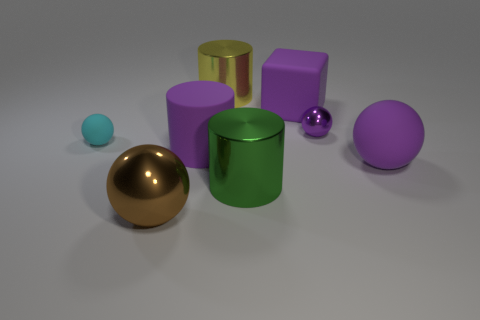What number of other objects are the same material as the large yellow thing?
Your response must be concise. 3. There is another sphere that is the same size as the brown metal sphere; what is it made of?
Your response must be concise. Rubber. Does the purple object on the left side of the purple cube have the same shape as the big thing that is on the right side of the tiny metallic thing?
Your response must be concise. No. There is a green thing that is the same size as the purple cylinder; what is its shape?
Provide a succinct answer. Cylinder. Is the large green thing in front of the large purple sphere made of the same material as the purple object that is on the left side of the yellow object?
Your answer should be very brief. No. There is a matte ball that is to the right of the brown metal sphere; are there any purple things that are left of it?
Provide a succinct answer. Yes. The cube that is the same material as the small cyan ball is what color?
Make the answer very short. Purple. Are there more cyan objects than tiny yellow cylinders?
Provide a succinct answer. Yes. How many things are large metallic cylinders behind the large purple rubber ball or large green metal objects?
Your answer should be very brief. 2. Is there a matte thing that has the same size as the purple rubber cube?
Make the answer very short. Yes. 